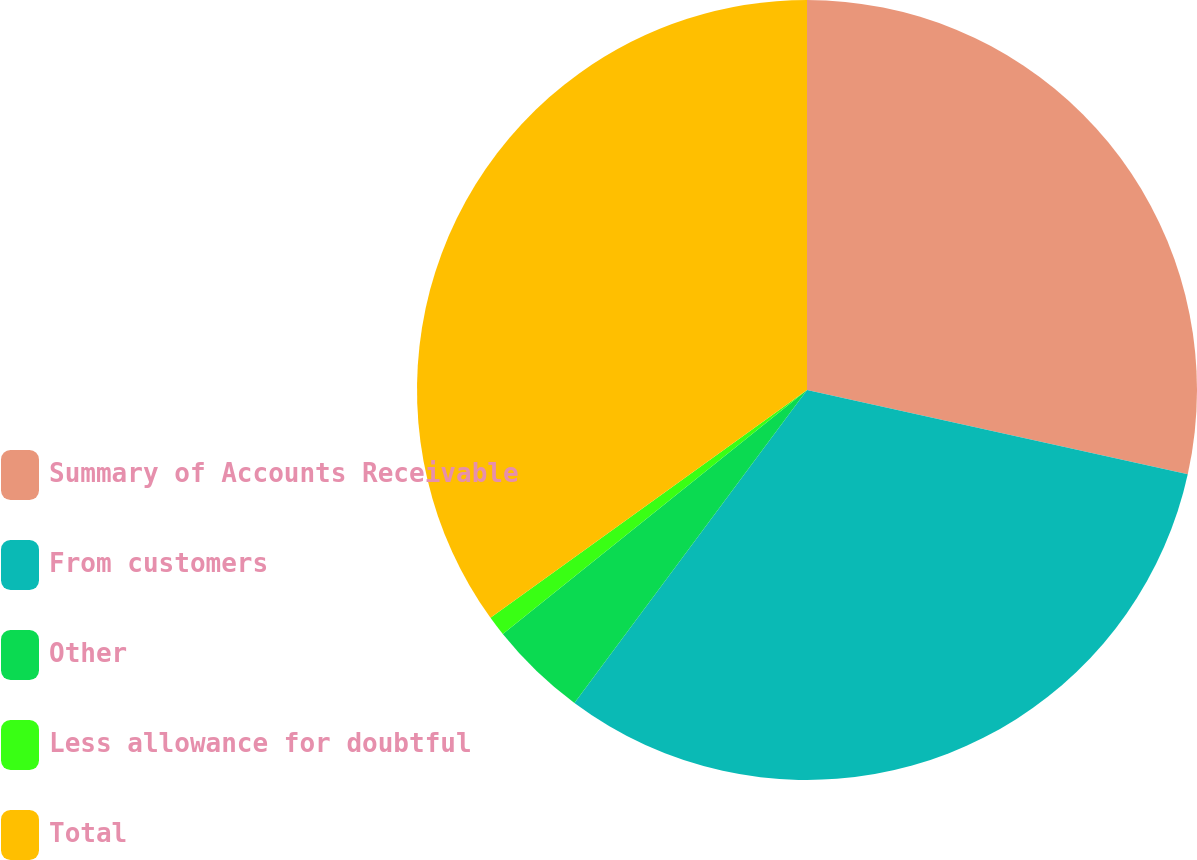<chart> <loc_0><loc_0><loc_500><loc_500><pie_chart><fcel>Summary of Accounts Receivable<fcel>From customers<fcel>Other<fcel>Less allowance for doubtful<fcel>Total<nl><fcel>28.47%<fcel>31.7%<fcel>4.07%<fcel>0.83%<fcel>34.93%<nl></chart> 